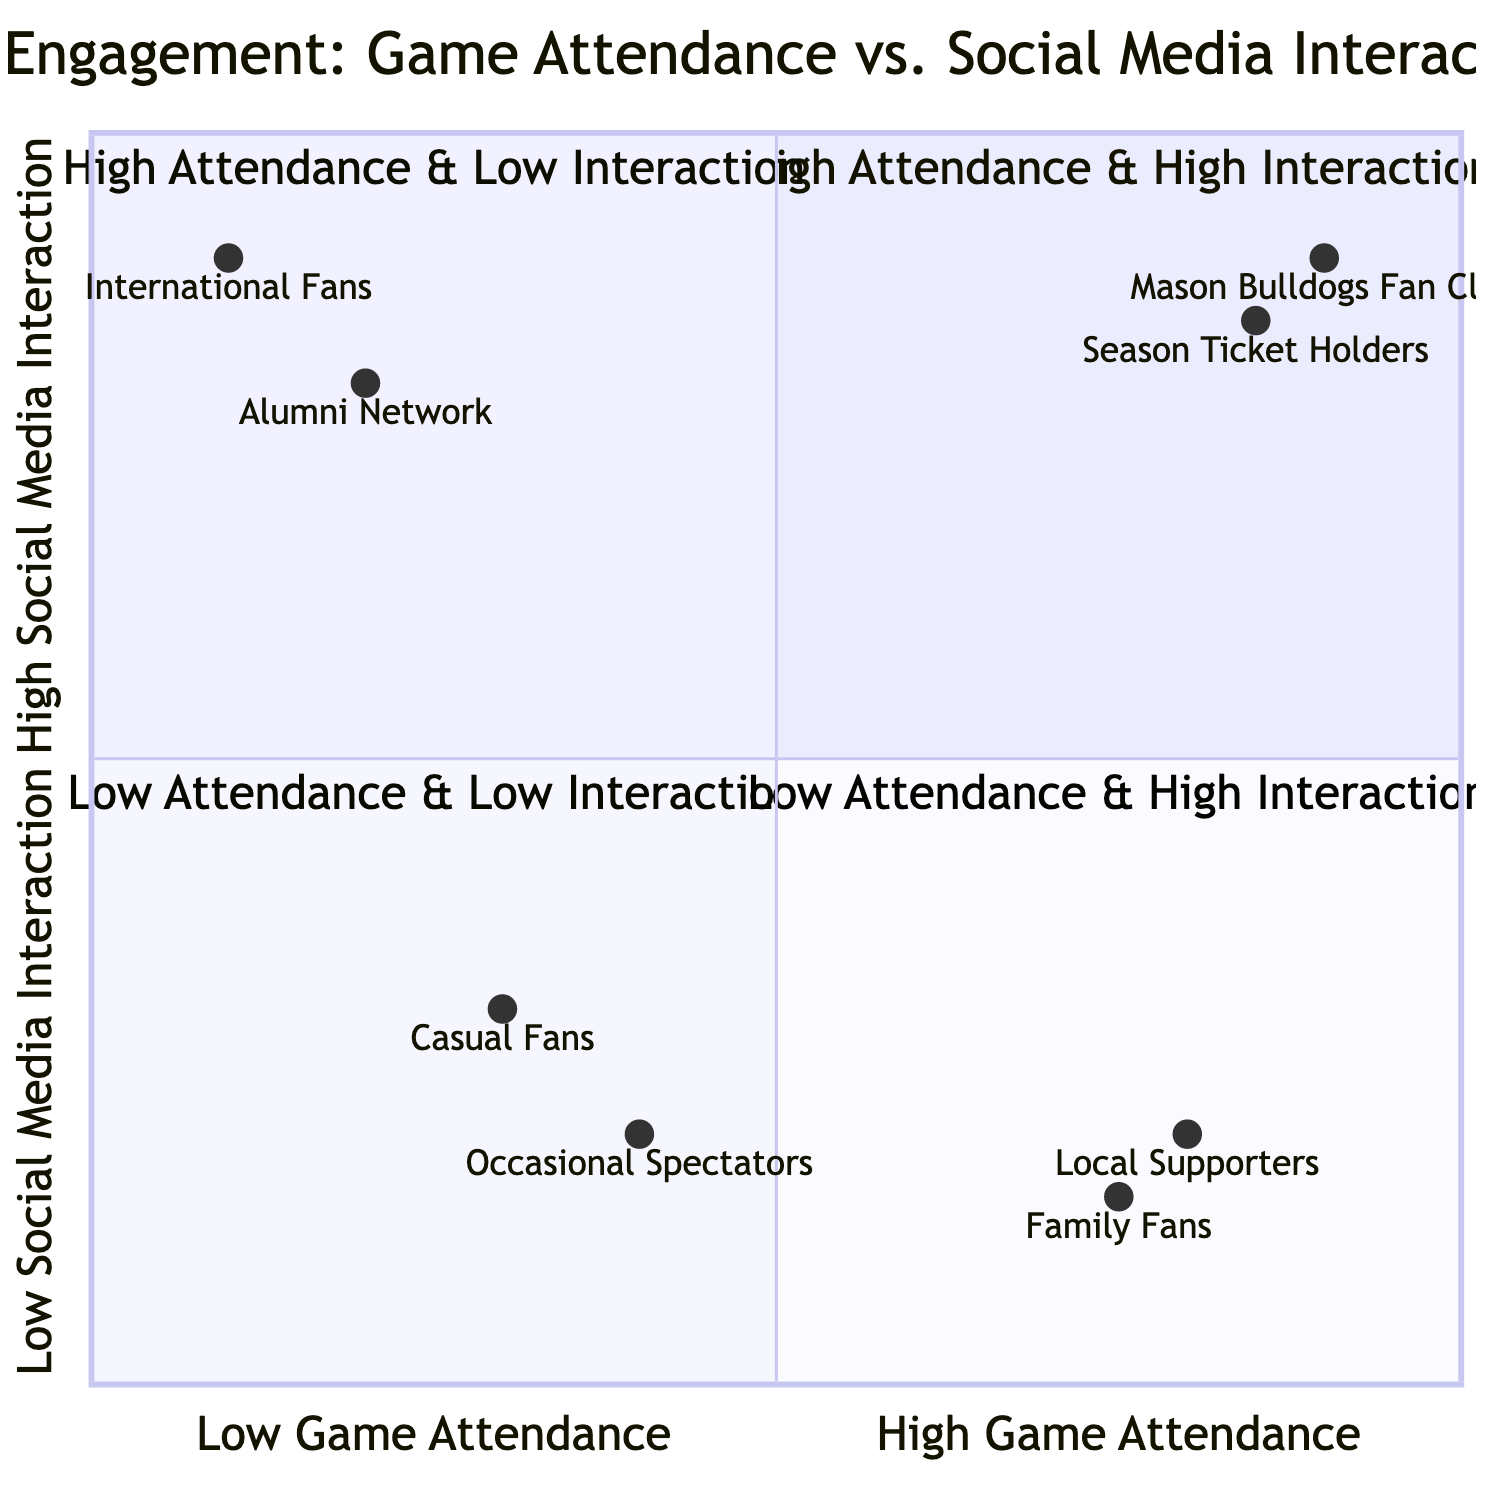What elements are in the High Game Attendance & High Social Media Interaction quadrant? This quadrant contains the elements "Mason Bulldogs Fan Club" and "Season Ticket Holders". By reviewing the diagram, we can identify these two elements specifically noted for both high attendance at games and active social media engagement.
Answer: Mason Bulldogs Fan Club, Season Ticket Holders Which fan group has the lowest social media interaction? The group with the lowest social media interaction, as seen in the diagram in the Low Attendance & Low Interaction quadrant, is "Occasional Spectators". No other group listed has a lower interaction level than this.
Answer: Occasional Spectators How many fan groups fall into the High Game Attendance & Low Social Media Interaction quadrant? The High Game Attendance & Low Social Media Interaction quadrant contains two groups: "Local Supporters" and "Family Fans". Thus, we can count them directly from the diagram to reach the answer.
Answer: 2 Which quadrant contains the "International Fans"? "International Fans" are located in the Low Game Attendance & High Social Media Interaction quadrant. This can be identified by looking at its classification based on their behaviors.
Answer: Low Game Attendance & High Social Media Interaction What is the social media interaction level of the Season Ticket Holders? The social media interaction level for "Season Ticket Holders" is 0.85, which is represented on the y-axis of the diagram in the High Game Attendance & High Social Media Interaction quadrant. This precise value indicates their active online engagement.
Answer: 0.85 Which two groups have high social media interaction but low game attendance? The two groups are "International Fans" and "Alumni Network", both found in the Low Game Attendance & High Social Media Interaction quadrant. A glance at that quadrant confirms these two groups' engagement level.
Answer: International Fans, Alumni Network How do the "Casual Fans" differ in attendance compared to the "Family Fans"? "Casual Fans" have a lower game attendance at 0.3, while "Family Fans" have a higher attendance at 0.75, indicating that families participate more frequently in games than casual fans do. This comparison is made based on the data points provided in the diagram.
Answer: Casual Fans have lower attendance What is the interaction level of the "Alumni Network"? The "Alumni Network" has a social media interaction level of 0.8, as indicated on the diagram. This can be verified by locating the group in the Low Game Attendance & High Social Media Interaction quadrant.
Answer: 0.8 